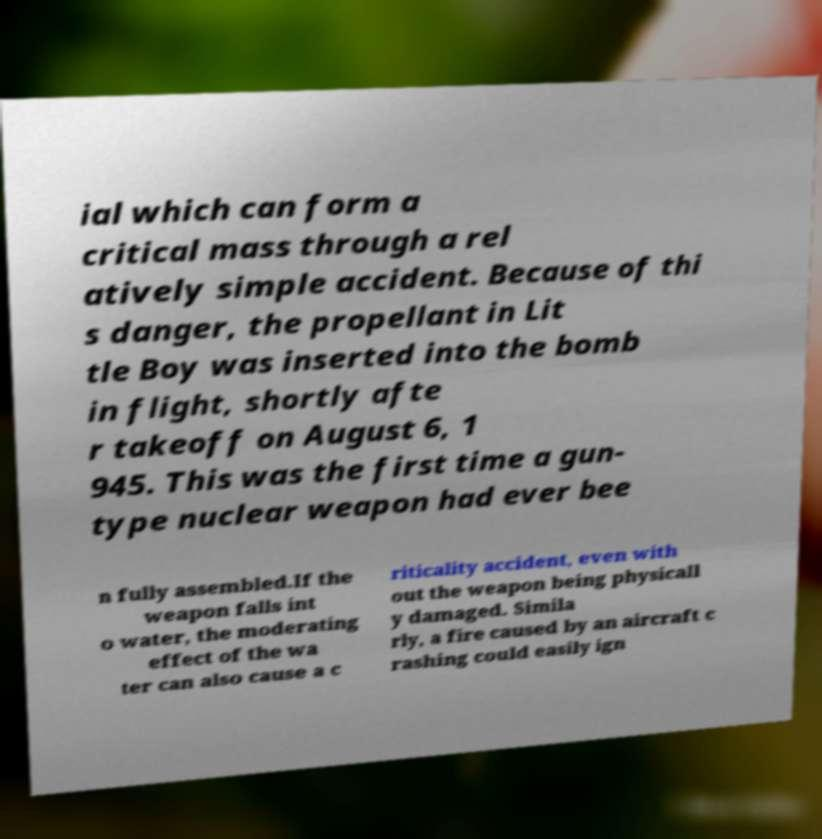Can you read and provide the text displayed in the image?This photo seems to have some interesting text. Can you extract and type it out for me? ial which can form a critical mass through a rel atively simple accident. Because of thi s danger, the propellant in Lit tle Boy was inserted into the bomb in flight, shortly afte r takeoff on August 6, 1 945. This was the first time a gun- type nuclear weapon had ever bee n fully assembled.If the weapon falls int o water, the moderating effect of the wa ter can also cause a c riticality accident, even with out the weapon being physicall y damaged. Simila rly, a fire caused by an aircraft c rashing could easily ign 